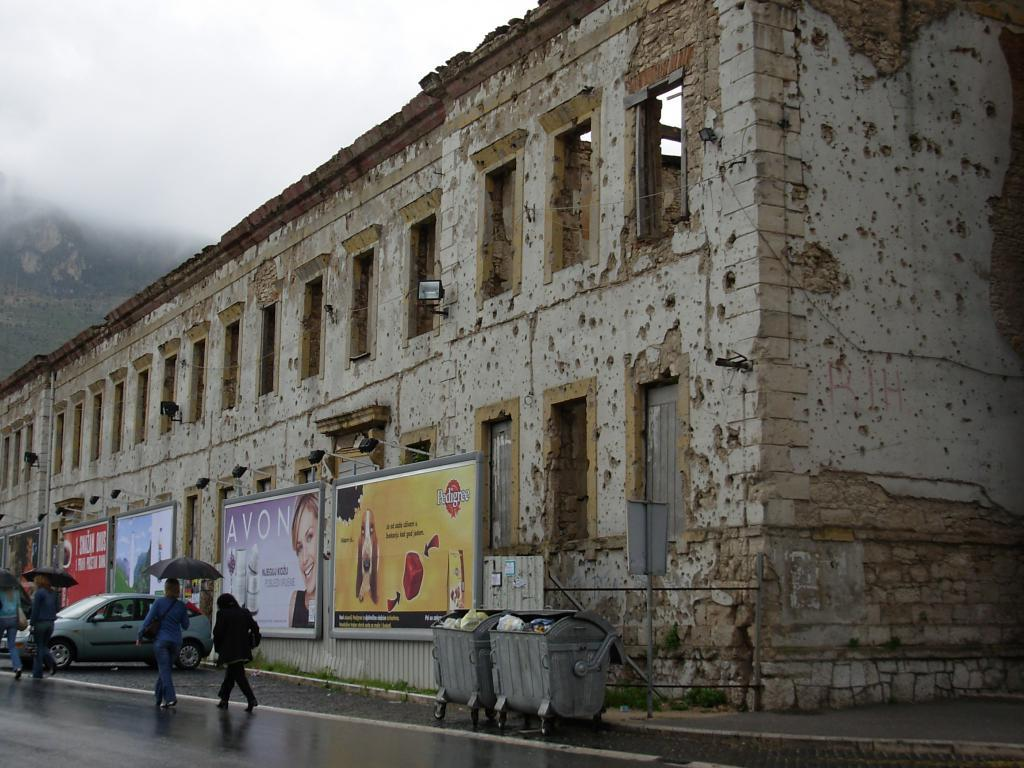<image>
Render a clear and concise summary of the photo. bulet pockmarked building shell is used for billboards advertising Pedigree dog food 